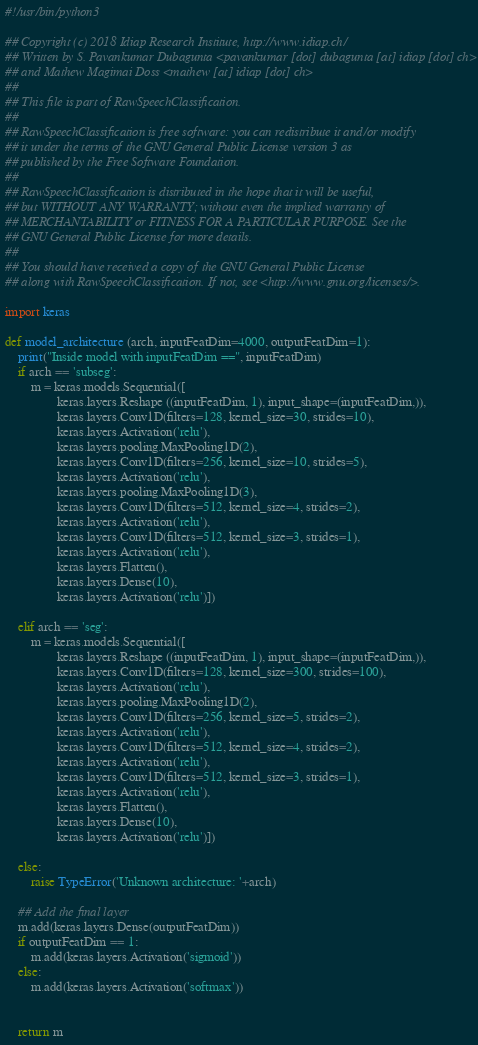Convert code to text. <code><loc_0><loc_0><loc_500><loc_500><_Python_>#!/usr/bin/python3

## Copyright (c) 2018 Idiap Research Institute, http://www.idiap.ch/
## Written by S. Pavankumar Dubagunta <pavankumar [dot] dubagunta [at] idiap [dot] ch>
## and Mathew Magimai Doss <mathew [at] idiap [dot] ch>
## 
## This file is part of RawSpeechClassification.
## 
## RawSpeechClassification is free software: you can redistribute it and/or modify
## it under the terms of the GNU General Public License version 3 as
## published by the Free Software Foundation.
## 
## RawSpeechClassification is distributed in the hope that it will be useful,
## but WITHOUT ANY WARRANTY; without even the implied warranty of
## MERCHANTABILITY or FITNESS FOR A PARTICULAR PURPOSE. See the
## GNU General Public License for more details.
## 
## You should have received a copy of the GNU General Public License
## along with RawSpeechClassification. If not, see <http://www.gnu.org/licenses/>.

import keras

def model_architecture (arch, inputFeatDim=4000, outputFeatDim=1):
    print("Inside model with inputFeatDim ==", inputFeatDim)
    if arch == 'subseg':
        m = keras.models.Sequential([
                keras.layers.Reshape ((inputFeatDim, 1), input_shape=(inputFeatDim,)),
                keras.layers.Conv1D(filters=128, kernel_size=30, strides=10),
                keras.layers.Activation('relu'),
                keras.layers.pooling.MaxPooling1D(2),
                keras.layers.Conv1D(filters=256, kernel_size=10, strides=5),
                keras.layers.Activation('relu'),
                keras.layers.pooling.MaxPooling1D(3),
                keras.layers.Conv1D(filters=512, kernel_size=4, strides=2),
                keras.layers.Activation('relu'),
                keras.layers.Conv1D(filters=512, kernel_size=3, strides=1),
                keras.layers.Activation('relu'),
                keras.layers.Flatten(),
                keras.layers.Dense(10),
                keras.layers.Activation('relu')])

    elif arch == 'seg':
        m = keras.models.Sequential([
                keras.layers.Reshape ((inputFeatDim, 1), input_shape=(inputFeatDim,)),
                keras.layers.Conv1D(filters=128, kernel_size=300, strides=100),
                keras.layers.Activation('relu'),
                keras.layers.pooling.MaxPooling1D(2),
                keras.layers.Conv1D(filters=256, kernel_size=5, strides=2),
                keras.layers.Activation('relu'),
                keras.layers.Conv1D(filters=512, kernel_size=4, strides=2),
                keras.layers.Activation('relu'),
                keras.layers.Conv1D(filters=512, kernel_size=3, strides=1),
                keras.layers.Activation('relu'),
                keras.layers.Flatten(),
                keras.layers.Dense(10),
                keras.layers.Activation('relu')])

    else:
        raise TypeError('Unknown architecture: '+arch)
 
    ## Add the final layer
    m.add(keras.layers.Dense(outputFeatDim))
    if outputFeatDim == 1:
        m.add(keras.layers.Activation('sigmoid'))
    else:
        m.add(keras.layers.Activation('softmax'))


    return m
</code> 